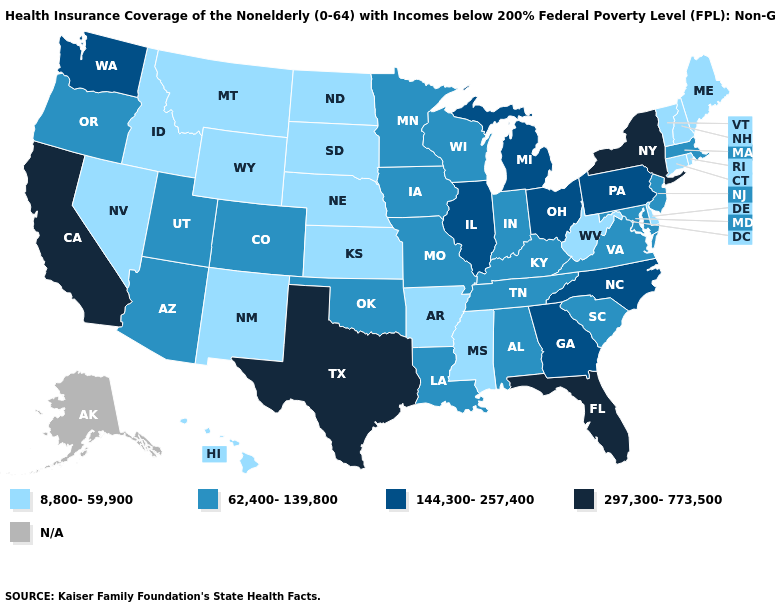Which states have the highest value in the USA?
Concise answer only. California, Florida, New York, Texas. What is the value of Alabama?
Concise answer only. 62,400-139,800. What is the highest value in the West ?
Be succinct. 297,300-773,500. Does New York have the highest value in the USA?
Be succinct. Yes. What is the value of North Dakota?
Concise answer only. 8,800-59,900. Among the states that border Washington , which have the lowest value?
Quick response, please. Idaho. Name the states that have a value in the range N/A?
Write a very short answer. Alaska. Does Massachusetts have the lowest value in the Northeast?
Be succinct. No. What is the lowest value in the USA?
Concise answer only. 8,800-59,900. Does the first symbol in the legend represent the smallest category?
Be succinct. Yes. Does Colorado have the highest value in the West?
Be succinct. No. Is the legend a continuous bar?
Give a very brief answer. No. Name the states that have a value in the range N/A?
Concise answer only. Alaska. What is the value of Delaware?
Be succinct. 8,800-59,900. 